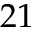Convert formula to latex. <formula><loc_0><loc_0><loc_500><loc_500>2 1</formula> 